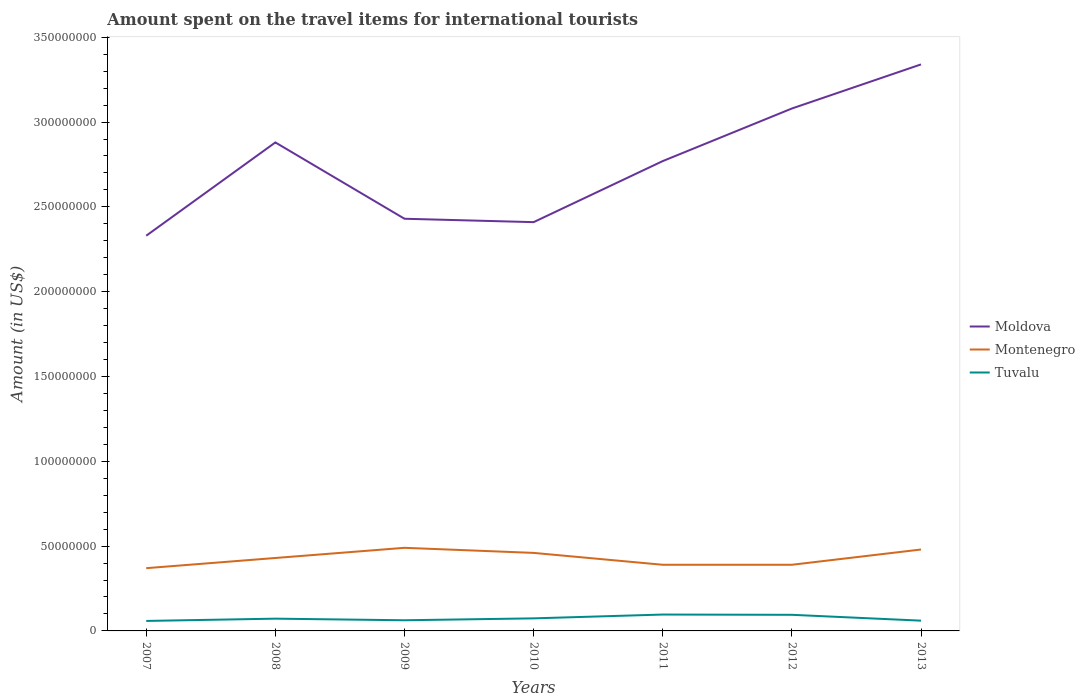How many different coloured lines are there?
Give a very brief answer. 3. Is the number of lines equal to the number of legend labels?
Your answer should be compact. Yes. Across all years, what is the maximum amount spent on the travel items for international tourists in Moldova?
Your answer should be compact. 2.33e+08. In which year was the amount spent on the travel items for international tourists in Montenegro maximum?
Make the answer very short. 2007. What is the total amount spent on the travel items for international tourists in Tuvalu in the graph?
Keep it short and to the point. -2.27e+06. What is the difference between the highest and the second highest amount spent on the travel items for international tourists in Moldova?
Make the answer very short. 1.01e+08. How many years are there in the graph?
Ensure brevity in your answer.  7. What is the difference between two consecutive major ticks on the Y-axis?
Ensure brevity in your answer.  5.00e+07. Are the values on the major ticks of Y-axis written in scientific E-notation?
Provide a succinct answer. No. Does the graph contain any zero values?
Ensure brevity in your answer.  No. How many legend labels are there?
Provide a succinct answer. 3. How are the legend labels stacked?
Your response must be concise. Vertical. What is the title of the graph?
Ensure brevity in your answer.  Amount spent on the travel items for international tourists. Does "Liberia" appear as one of the legend labels in the graph?
Keep it short and to the point. No. What is the label or title of the Y-axis?
Offer a very short reply. Amount (in US$). What is the Amount (in US$) in Moldova in 2007?
Your answer should be compact. 2.33e+08. What is the Amount (in US$) in Montenegro in 2007?
Keep it short and to the point. 3.70e+07. What is the Amount (in US$) of Tuvalu in 2007?
Your answer should be very brief. 5.89e+06. What is the Amount (in US$) of Moldova in 2008?
Ensure brevity in your answer.  2.88e+08. What is the Amount (in US$) of Montenegro in 2008?
Make the answer very short. 4.30e+07. What is the Amount (in US$) in Tuvalu in 2008?
Your answer should be very brief. 7.23e+06. What is the Amount (in US$) of Moldova in 2009?
Make the answer very short. 2.43e+08. What is the Amount (in US$) of Montenegro in 2009?
Your response must be concise. 4.90e+07. What is the Amount (in US$) of Tuvalu in 2009?
Provide a short and direct response. 6.28e+06. What is the Amount (in US$) in Moldova in 2010?
Offer a very short reply. 2.41e+08. What is the Amount (in US$) in Montenegro in 2010?
Give a very brief answer. 4.60e+07. What is the Amount (in US$) in Tuvalu in 2010?
Your answer should be very brief. 7.41e+06. What is the Amount (in US$) of Moldova in 2011?
Offer a terse response. 2.77e+08. What is the Amount (in US$) in Montenegro in 2011?
Keep it short and to the point. 3.90e+07. What is the Amount (in US$) in Tuvalu in 2011?
Give a very brief answer. 9.65e+06. What is the Amount (in US$) in Moldova in 2012?
Your answer should be compact. 3.08e+08. What is the Amount (in US$) in Montenegro in 2012?
Provide a succinct answer. 3.90e+07. What is the Amount (in US$) of Tuvalu in 2012?
Ensure brevity in your answer.  9.50e+06. What is the Amount (in US$) in Moldova in 2013?
Make the answer very short. 3.34e+08. What is the Amount (in US$) in Montenegro in 2013?
Your response must be concise. 4.80e+07. What is the Amount (in US$) in Tuvalu in 2013?
Provide a short and direct response. 6.05e+06. Across all years, what is the maximum Amount (in US$) of Moldova?
Make the answer very short. 3.34e+08. Across all years, what is the maximum Amount (in US$) of Montenegro?
Ensure brevity in your answer.  4.90e+07. Across all years, what is the maximum Amount (in US$) in Tuvalu?
Offer a very short reply. 9.65e+06. Across all years, what is the minimum Amount (in US$) in Moldova?
Keep it short and to the point. 2.33e+08. Across all years, what is the minimum Amount (in US$) of Montenegro?
Offer a terse response. 3.70e+07. Across all years, what is the minimum Amount (in US$) of Tuvalu?
Give a very brief answer. 5.89e+06. What is the total Amount (in US$) in Moldova in the graph?
Make the answer very short. 1.92e+09. What is the total Amount (in US$) of Montenegro in the graph?
Offer a very short reply. 3.01e+08. What is the total Amount (in US$) of Tuvalu in the graph?
Provide a short and direct response. 5.20e+07. What is the difference between the Amount (in US$) of Moldova in 2007 and that in 2008?
Provide a short and direct response. -5.50e+07. What is the difference between the Amount (in US$) of Montenegro in 2007 and that in 2008?
Offer a terse response. -6.00e+06. What is the difference between the Amount (in US$) of Tuvalu in 2007 and that in 2008?
Offer a very short reply. -1.34e+06. What is the difference between the Amount (in US$) of Moldova in 2007 and that in 2009?
Ensure brevity in your answer.  -1.00e+07. What is the difference between the Amount (in US$) of Montenegro in 2007 and that in 2009?
Provide a succinct answer. -1.20e+07. What is the difference between the Amount (in US$) of Tuvalu in 2007 and that in 2009?
Your response must be concise. -3.90e+05. What is the difference between the Amount (in US$) of Moldova in 2007 and that in 2010?
Your answer should be very brief. -8.00e+06. What is the difference between the Amount (in US$) of Montenegro in 2007 and that in 2010?
Your response must be concise. -9.00e+06. What is the difference between the Amount (in US$) in Tuvalu in 2007 and that in 2010?
Make the answer very short. -1.52e+06. What is the difference between the Amount (in US$) in Moldova in 2007 and that in 2011?
Provide a short and direct response. -4.40e+07. What is the difference between the Amount (in US$) in Tuvalu in 2007 and that in 2011?
Keep it short and to the point. -3.76e+06. What is the difference between the Amount (in US$) of Moldova in 2007 and that in 2012?
Provide a succinct answer. -7.50e+07. What is the difference between the Amount (in US$) in Tuvalu in 2007 and that in 2012?
Your response must be concise. -3.61e+06. What is the difference between the Amount (in US$) of Moldova in 2007 and that in 2013?
Your response must be concise. -1.01e+08. What is the difference between the Amount (in US$) of Montenegro in 2007 and that in 2013?
Your response must be concise. -1.10e+07. What is the difference between the Amount (in US$) of Moldova in 2008 and that in 2009?
Keep it short and to the point. 4.50e+07. What is the difference between the Amount (in US$) of Montenegro in 2008 and that in 2009?
Offer a terse response. -6.00e+06. What is the difference between the Amount (in US$) of Tuvalu in 2008 and that in 2009?
Provide a succinct answer. 9.50e+05. What is the difference between the Amount (in US$) of Moldova in 2008 and that in 2010?
Offer a terse response. 4.70e+07. What is the difference between the Amount (in US$) of Montenegro in 2008 and that in 2010?
Give a very brief answer. -3.00e+06. What is the difference between the Amount (in US$) of Moldova in 2008 and that in 2011?
Your answer should be very brief. 1.10e+07. What is the difference between the Amount (in US$) in Tuvalu in 2008 and that in 2011?
Your answer should be very brief. -2.42e+06. What is the difference between the Amount (in US$) in Moldova in 2008 and that in 2012?
Give a very brief answer. -2.00e+07. What is the difference between the Amount (in US$) in Tuvalu in 2008 and that in 2012?
Provide a succinct answer. -2.27e+06. What is the difference between the Amount (in US$) of Moldova in 2008 and that in 2013?
Provide a short and direct response. -4.60e+07. What is the difference between the Amount (in US$) of Montenegro in 2008 and that in 2013?
Make the answer very short. -5.00e+06. What is the difference between the Amount (in US$) in Tuvalu in 2008 and that in 2013?
Provide a short and direct response. 1.18e+06. What is the difference between the Amount (in US$) of Montenegro in 2009 and that in 2010?
Offer a very short reply. 3.00e+06. What is the difference between the Amount (in US$) of Tuvalu in 2009 and that in 2010?
Ensure brevity in your answer.  -1.13e+06. What is the difference between the Amount (in US$) in Moldova in 2009 and that in 2011?
Provide a short and direct response. -3.40e+07. What is the difference between the Amount (in US$) of Montenegro in 2009 and that in 2011?
Your response must be concise. 1.00e+07. What is the difference between the Amount (in US$) of Tuvalu in 2009 and that in 2011?
Provide a succinct answer. -3.37e+06. What is the difference between the Amount (in US$) in Moldova in 2009 and that in 2012?
Your answer should be very brief. -6.50e+07. What is the difference between the Amount (in US$) of Montenegro in 2009 and that in 2012?
Offer a terse response. 1.00e+07. What is the difference between the Amount (in US$) of Tuvalu in 2009 and that in 2012?
Your response must be concise. -3.22e+06. What is the difference between the Amount (in US$) in Moldova in 2009 and that in 2013?
Make the answer very short. -9.10e+07. What is the difference between the Amount (in US$) of Montenegro in 2009 and that in 2013?
Provide a succinct answer. 1.00e+06. What is the difference between the Amount (in US$) in Tuvalu in 2009 and that in 2013?
Offer a very short reply. 2.30e+05. What is the difference between the Amount (in US$) of Moldova in 2010 and that in 2011?
Provide a short and direct response. -3.60e+07. What is the difference between the Amount (in US$) in Montenegro in 2010 and that in 2011?
Offer a very short reply. 7.00e+06. What is the difference between the Amount (in US$) of Tuvalu in 2010 and that in 2011?
Keep it short and to the point. -2.24e+06. What is the difference between the Amount (in US$) in Moldova in 2010 and that in 2012?
Your answer should be compact. -6.70e+07. What is the difference between the Amount (in US$) of Tuvalu in 2010 and that in 2012?
Your response must be concise. -2.09e+06. What is the difference between the Amount (in US$) in Moldova in 2010 and that in 2013?
Give a very brief answer. -9.30e+07. What is the difference between the Amount (in US$) in Tuvalu in 2010 and that in 2013?
Offer a terse response. 1.36e+06. What is the difference between the Amount (in US$) in Moldova in 2011 and that in 2012?
Your response must be concise. -3.10e+07. What is the difference between the Amount (in US$) in Montenegro in 2011 and that in 2012?
Your answer should be compact. 0. What is the difference between the Amount (in US$) in Moldova in 2011 and that in 2013?
Your response must be concise. -5.70e+07. What is the difference between the Amount (in US$) in Montenegro in 2011 and that in 2013?
Offer a terse response. -9.00e+06. What is the difference between the Amount (in US$) in Tuvalu in 2011 and that in 2013?
Give a very brief answer. 3.60e+06. What is the difference between the Amount (in US$) of Moldova in 2012 and that in 2013?
Provide a succinct answer. -2.60e+07. What is the difference between the Amount (in US$) of Montenegro in 2012 and that in 2013?
Ensure brevity in your answer.  -9.00e+06. What is the difference between the Amount (in US$) in Tuvalu in 2012 and that in 2013?
Provide a short and direct response. 3.45e+06. What is the difference between the Amount (in US$) of Moldova in 2007 and the Amount (in US$) of Montenegro in 2008?
Provide a succinct answer. 1.90e+08. What is the difference between the Amount (in US$) of Moldova in 2007 and the Amount (in US$) of Tuvalu in 2008?
Make the answer very short. 2.26e+08. What is the difference between the Amount (in US$) of Montenegro in 2007 and the Amount (in US$) of Tuvalu in 2008?
Offer a very short reply. 2.98e+07. What is the difference between the Amount (in US$) in Moldova in 2007 and the Amount (in US$) in Montenegro in 2009?
Your response must be concise. 1.84e+08. What is the difference between the Amount (in US$) in Moldova in 2007 and the Amount (in US$) in Tuvalu in 2009?
Provide a succinct answer. 2.27e+08. What is the difference between the Amount (in US$) in Montenegro in 2007 and the Amount (in US$) in Tuvalu in 2009?
Your answer should be very brief. 3.07e+07. What is the difference between the Amount (in US$) in Moldova in 2007 and the Amount (in US$) in Montenegro in 2010?
Your answer should be compact. 1.87e+08. What is the difference between the Amount (in US$) in Moldova in 2007 and the Amount (in US$) in Tuvalu in 2010?
Provide a short and direct response. 2.26e+08. What is the difference between the Amount (in US$) in Montenegro in 2007 and the Amount (in US$) in Tuvalu in 2010?
Your answer should be compact. 2.96e+07. What is the difference between the Amount (in US$) of Moldova in 2007 and the Amount (in US$) of Montenegro in 2011?
Give a very brief answer. 1.94e+08. What is the difference between the Amount (in US$) of Moldova in 2007 and the Amount (in US$) of Tuvalu in 2011?
Make the answer very short. 2.23e+08. What is the difference between the Amount (in US$) in Montenegro in 2007 and the Amount (in US$) in Tuvalu in 2011?
Provide a succinct answer. 2.74e+07. What is the difference between the Amount (in US$) in Moldova in 2007 and the Amount (in US$) in Montenegro in 2012?
Provide a short and direct response. 1.94e+08. What is the difference between the Amount (in US$) of Moldova in 2007 and the Amount (in US$) of Tuvalu in 2012?
Give a very brief answer. 2.24e+08. What is the difference between the Amount (in US$) in Montenegro in 2007 and the Amount (in US$) in Tuvalu in 2012?
Ensure brevity in your answer.  2.75e+07. What is the difference between the Amount (in US$) in Moldova in 2007 and the Amount (in US$) in Montenegro in 2013?
Give a very brief answer. 1.85e+08. What is the difference between the Amount (in US$) in Moldova in 2007 and the Amount (in US$) in Tuvalu in 2013?
Make the answer very short. 2.27e+08. What is the difference between the Amount (in US$) in Montenegro in 2007 and the Amount (in US$) in Tuvalu in 2013?
Give a very brief answer. 3.10e+07. What is the difference between the Amount (in US$) of Moldova in 2008 and the Amount (in US$) of Montenegro in 2009?
Your response must be concise. 2.39e+08. What is the difference between the Amount (in US$) in Moldova in 2008 and the Amount (in US$) in Tuvalu in 2009?
Provide a short and direct response. 2.82e+08. What is the difference between the Amount (in US$) of Montenegro in 2008 and the Amount (in US$) of Tuvalu in 2009?
Your response must be concise. 3.67e+07. What is the difference between the Amount (in US$) of Moldova in 2008 and the Amount (in US$) of Montenegro in 2010?
Make the answer very short. 2.42e+08. What is the difference between the Amount (in US$) in Moldova in 2008 and the Amount (in US$) in Tuvalu in 2010?
Make the answer very short. 2.81e+08. What is the difference between the Amount (in US$) of Montenegro in 2008 and the Amount (in US$) of Tuvalu in 2010?
Make the answer very short. 3.56e+07. What is the difference between the Amount (in US$) in Moldova in 2008 and the Amount (in US$) in Montenegro in 2011?
Your answer should be compact. 2.49e+08. What is the difference between the Amount (in US$) in Moldova in 2008 and the Amount (in US$) in Tuvalu in 2011?
Your response must be concise. 2.78e+08. What is the difference between the Amount (in US$) in Montenegro in 2008 and the Amount (in US$) in Tuvalu in 2011?
Provide a succinct answer. 3.34e+07. What is the difference between the Amount (in US$) of Moldova in 2008 and the Amount (in US$) of Montenegro in 2012?
Offer a terse response. 2.49e+08. What is the difference between the Amount (in US$) in Moldova in 2008 and the Amount (in US$) in Tuvalu in 2012?
Provide a short and direct response. 2.78e+08. What is the difference between the Amount (in US$) in Montenegro in 2008 and the Amount (in US$) in Tuvalu in 2012?
Offer a very short reply. 3.35e+07. What is the difference between the Amount (in US$) of Moldova in 2008 and the Amount (in US$) of Montenegro in 2013?
Give a very brief answer. 2.40e+08. What is the difference between the Amount (in US$) of Moldova in 2008 and the Amount (in US$) of Tuvalu in 2013?
Provide a succinct answer. 2.82e+08. What is the difference between the Amount (in US$) of Montenegro in 2008 and the Amount (in US$) of Tuvalu in 2013?
Provide a succinct answer. 3.70e+07. What is the difference between the Amount (in US$) in Moldova in 2009 and the Amount (in US$) in Montenegro in 2010?
Make the answer very short. 1.97e+08. What is the difference between the Amount (in US$) of Moldova in 2009 and the Amount (in US$) of Tuvalu in 2010?
Make the answer very short. 2.36e+08. What is the difference between the Amount (in US$) in Montenegro in 2009 and the Amount (in US$) in Tuvalu in 2010?
Your response must be concise. 4.16e+07. What is the difference between the Amount (in US$) of Moldova in 2009 and the Amount (in US$) of Montenegro in 2011?
Your answer should be very brief. 2.04e+08. What is the difference between the Amount (in US$) in Moldova in 2009 and the Amount (in US$) in Tuvalu in 2011?
Provide a succinct answer. 2.33e+08. What is the difference between the Amount (in US$) in Montenegro in 2009 and the Amount (in US$) in Tuvalu in 2011?
Ensure brevity in your answer.  3.94e+07. What is the difference between the Amount (in US$) in Moldova in 2009 and the Amount (in US$) in Montenegro in 2012?
Offer a very short reply. 2.04e+08. What is the difference between the Amount (in US$) of Moldova in 2009 and the Amount (in US$) of Tuvalu in 2012?
Offer a terse response. 2.34e+08. What is the difference between the Amount (in US$) in Montenegro in 2009 and the Amount (in US$) in Tuvalu in 2012?
Provide a succinct answer. 3.95e+07. What is the difference between the Amount (in US$) in Moldova in 2009 and the Amount (in US$) in Montenegro in 2013?
Keep it short and to the point. 1.95e+08. What is the difference between the Amount (in US$) in Moldova in 2009 and the Amount (in US$) in Tuvalu in 2013?
Ensure brevity in your answer.  2.37e+08. What is the difference between the Amount (in US$) of Montenegro in 2009 and the Amount (in US$) of Tuvalu in 2013?
Provide a succinct answer. 4.30e+07. What is the difference between the Amount (in US$) in Moldova in 2010 and the Amount (in US$) in Montenegro in 2011?
Offer a very short reply. 2.02e+08. What is the difference between the Amount (in US$) in Moldova in 2010 and the Amount (in US$) in Tuvalu in 2011?
Make the answer very short. 2.31e+08. What is the difference between the Amount (in US$) in Montenegro in 2010 and the Amount (in US$) in Tuvalu in 2011?
Provide a short and direct response. 3.64e+07. What is the difference between the Amount (in US$) in Moldova in 2010 and the Amount (in US$) in Montenegro in 2012?
Offer a very short reply. 2.02e+08. What is the difference between the Amount (in US$) of Moldova in 2010 and the Amount (in US$) of Tuvalu in 2012?
Offer a terse response. 2.32e+08. What is the difference between the Amount (in US$) of Montenegro in 2010 and the Amount (in US$) of Tuvalu in 2012?
Keep it short and to the point. 3.65e+07. What is the difference between the Amount (in US$) in Moldova in 2010 and the Amount (in US$) in Montenegro in 2013?
Ensure brevity in your answer.  1.93e+08. What is the difference between the Amount (in US$) of Moldova in 2010 and the Amount (in US$) of Tuvalu in 2013?
Provide a succinct answer. 2.35e+08. What is the difference between the Amount (in US$) in Montenegro in 2010 and the Amount (in US$) in Tuvalu in 2013?
Make the answer very short. 4.00e+07. What is the difference between the Amount (in US$) in Moldova in 2011 and the Amount (in US$) in Montenegro in 2012?
Make the answer very short. 2.38e+08. What is the difference between the Amount (in US$) of Moldova in 2011 and the Amount (in US$) of Tuvalu in 2012?
Make the answer very short. 2.68e+08. What is the difference between the Amount (in US$) of Montenegro in 2011 and the Amount (in US$) of Tuvalu in 2012?
Provide a succinct answer. 2.95e+07. What is the difference between the Amount (in US$) in Moldova in 2011 and the Amount (in US$) in Montenegro in 2013?
Your answer should be compact. 2.29e+08. What is the difference between the Amount (in US$) of Moldova in 2011 and the Amount (in US$) of Tuvalu in 2013?
Provide a short and direct response. 2.71e+08. What is the difference between the Amount (in US$) in Montenegro in 2011 and the Amount (in US$) in Tuvalu in 2013?
Your answer should be very brief. 3.30e+07. What is the difference between the Amount (in US$) in Moldova in 2012 and the Amount (in US$) in Montenegro in 2013?
Your answer should be compact. 2.60e+08. What is the difference between the Amount (in US$) of Moldova in 2012 and the Amount (in US$) of Tuvalu in 2013?
Make the answer very short. 3.02e+08. What is the difference between the Amount (in US$) in Montenegro in 2012 and the Amount (in US$) in Tuvalu in 2013?
Keep it short and to the point. 3.30e+07. What is the average Amount (in US$) in Moldova per year?
Your answer should be compact. 2.75e+08. What is the average Amount (in US$) of Montenegro per year?
Your response must be concise. 4.30e+07. What is the average Amount (in US$) in Tuvalu per year?
Make the answer very short. 7.43e+06. In the year 2007, what is the difference between the Amount (in US$) in Moldova and Amount (in US$) in Montenegro?
Keep it short and to the point. 1.96e+08. In the year 2007, what is the difference between the Amount (in US$) of Moldova and Amount (in US$) of Tuvalu?
Your answer should be very brief. 2.27e+08. In the year 2007, what is the difference between the Amount (in US$) of Montenegro and Amount (in US$) of Tuvalu?
Provide a short and direct response. 3.11e+07. In the year 2008, what is the difference between the Amount (in US$) in Moldova and Amount (in US$) in Montenegro?
Make the answer very short. 2.45e+08. In the year 2008, what is the difference between the Amount (in US$) of Moldova and Amount (in US$) of Tuvalu?
Keep it short and to the point. 2.81e+08. In the year 2008, what is the difference between the Amount (in US$) in Montenegro and Amount (in US$) in Tuvalu?
Your answer should be compact. 3.58e+07. In the year 2009, what is the difference between the Amount (in US$) in Moldova and Amount (in US$) in Montenegro?
Your answer should be very brief. 1.94e+08. In the year 2009, what is the difference between the Amount (in US$) of Moldova and Amount (in US$) of Tuvalu?
Provide a short and direct response. 2.37e+08. In the year 2009, what is the difference between the Amount (in US$) in Montenegro and Amount (in US$) in Tuvalu?
Offer a very short reply. 4.27e+07. In the year 2010, what is the difference between the Amount (in US$) of Moldova and Amount (in US$) of Montenegro?
Ensure brevity in your answer.  1.95e+08. In the year 2010, what is the difference between the Amount (in US$) of Moldova and Amount (in US$) of Tuvalu?
Your answer should be compact. 2.34e+08. In the year 2010, what is the difference between the Amount (in US$) in Montenegro and Amount (in US$) in Tuvalu?
Your response must be concise. 3.86e+07. In the year 2011, what is the difference between the Amount (in US$) in Moldova and Amount (in US$) in Montenegro?
Provide a short and direct response. 2.38e+08. In the year 2011, what is the difference between the Amount (in US$) of Moldova and Amount (in US$) of Tuvalu?
Keep it short and to the point. 2.67e+08. In the year 2011, what is the difference between the Amount (in US$) of Montenegro and Amount (in US$) of Tuvalu?
Ensure brevity in your answer.  2.94e+07. In the year 2012, what is the difference between the Amount (in US$) of Moldova and Amount (in US$) of Montenegro?
Provide a succinct answer. 2.69e+08. In the year 2012, what is the difference between the Amount (in US$) of Moldova and Amount (in US$) of Tuvalu?
Make the answer very short. 2.98e+08. In the year 2012, what is the difference between the Amount (in US$) of Montenegro and Amount (in US$) of Tuvalu?
Give a very brief answer. 2.95e+07. In the year 2013, what is the difference between the Amount (in US$) in Moldova and Amount (in US$) in Montenegro?
Keep it short and to the point. 2.86e+08. In the year 2013, what is the difference between the Amount (in US$) of Moldova and Amount (in US$) of Tuvalu?
Your response must be concise. 3.28e+08. In the year 2013, what is the difference between the Amount (in US$) in Montenegro and Amount (in US$) in Tuvalu?
Make the answer very short. 4.20e+07. What is the ratio of the Amount (in US$) of Moldova in 2007 to that in 2008?
Your answer should be very brief. 0.81. What is the ratio of the Amount (in US$) in Montenegro in 2007 to that in 2008?
Provide a succinct answer. 0.86. What is the ratio of the Amount (in US$) of Tuvalu in 2007 to that in 2008?
Keep it short and to the point. 0.81. What is the ratio of the Amount (in US$) in Moldova in 2007 to that in 2009?
Ensure brevity in your answer.  0.96. What is the ratio of the Amount (in US$) in Montenegro in 2007 to that in 2009?
Your response must be concise. 0.76. What is the ratio of the Amount (in US$) of Tuvalu in 2007 to that in 2009?
Give a very brief answer. 0.94. What is the ratio of the Amount (in US$) of Moldova in 2007 to that in 2010?
Offer a very short reply. 0.97. What is the ratio of the Amount (in US$) of Montenegro in 2007 to that in 2010?
Ensure brevity in your answer.  0.8. What is the ratio of the Amount (in US$) in Tuvalu in 2007 to that in 2010?
Ensure brevity in your answer.  0.79. What is the ratio of the Amount (in US$) in Moldova in 2007 to that in 2011?
Your answer should be very brief. 0.84. What is the ratio of the Amount (in US$) of Montenegro in 2007 to that in 2011?
Your answer should be very brief. 0.95. What is the ratio of the Amount (in US$) in Tuvalu in 2007 to that in 2011?
Keep it short and to the point. 0.61. What is the ratio of the Amount (in US$) in Moldova in 2007 to that in 2012?
Your response must be concise. 0.76. What is the ratio of the Amount (in US$) of Montenegro in 2007 to that in 2012?
Your answer should be compact. 0.95. What is the ratio of the Amount (in US$) in Tuvalu in 2007 to that in 2012?
Your answer should be compact. 0.62. What is the ratio of the Amount (in US$) of Moldova in 2007 to that in 2013?
Ensure brevity in your answer.  0.7. What is the ratio of the Amount (in US$) of Montenegro in 2007 to that in 2013?
Make the answer very short. 0.77. What is the ratio of the Amount (in US$) of Tuvalu in 2007 to that in 2013?
Provide a short and direct response. 0.97. What is the ratio of the Amount (in US$) of Moldova in 2008 to that in 2009?
Offer a very short reply. 1.19. What is the ratio of the Amount (in US$) in Montenegro in 2008 to that in 2009?
Your answer should be compact. 0.88. What is the ratio of the Amount (in US$) of Tuvalu in 2008 to that in 2009?
Keep it short and to the point. 1.15. What is the ratio of the Amount (in US$) of Moldova in 2008 to that in 2010?
Ensure brevity in your answer.  1.2. What is the ratio of the Amount (in US$) in Montenegro in 2008 to that in 2010?
Offer a very short reply. 0.93. What is the ratio of the Amount (in US$) in Tuvalu in 2008 to that in 2010?
Your response must be concise. 0.98. What is the ratio of the Amount (in US$) in Moldova in 2008 to that in 2011?
Offer a terse response. 1.04. What is the ratio of the Amount (in US$) in Montenegro in 2008 to that in 2011?
Ensure brevity in your answer.  1.1. What is the ratio of the Amount (in US$) in Tuvalu in 2008 to that in 2011?
Make the answer very short. 0.75. What is the ratio of the Amount (in US$) of Moldova in 2008 to that in 2012?
Offer a terse response. 0.94. What is the ratio of the Amount (in US$) of Montenegro in 2008 to that in 2012?
Provide a succinct answer. 1.1. What is the ratio of the Amount (in US$) of Tuvalu in 2008 to that in 2012?
Ensure brevity in your answer.  0.76. What is the ratio of the Amount (in US$) of Moldova in 2008 to that in 2013?
Your response must be concise. 0.86. What is the ratio of the Amount (in US$) of Montenegro in 2008 to that in 2013?
Offer a terse response. 0.9. What is the ratio of the Amount (in US$) in Tuvalu in 2008 to that in 2013?
Give a very brief answer. 1.2. What is the ratio of the Amount (in US$) in Moldova in 2009 to that in 2010?
Provide a succinct answer. 1.01. What is the ratio of the Amount (in US$) of Montenegro in 2009 to that in 2010?
Ensure brevity in your answer.  1.07. What is the ratio of the Amount (in US$) of Tuvalu in 2009 to that in 2010?
Provide a succinct answer. 0.85. What is the ratio of the Amount (in US$) of Moldova in 2009 to that in 2011?
Provide a succinct answer. 0.88. What is the ratio of the Amount (in US$) in Montenegro in 2009 to that in 2011?
Your answer should be very brief. 1.26. What is the ratio of the Amount (in US$) in Tuvalu in 2009 to that in 2011?
Keep it short and to the point. 0.65. What is the ratio of the Amount (in US$) of Moldova in 2009 to that in 2012?
Your answer should be compact. 0.79. What is the ratio of the Amount (in US$) in Montenegro in 2009 to that in 2012?
Your answer should be very brief. 1.26. What is the ratio of the Amount (in US$) of Tuvalu in 2009 to that in 2012?
Ensure brevity in your answer.  0.66. What is the ratio of the Amount (in US$) in Moldova in 2009 to that in 2013?
Your answer should be compact. 0.73. What is the ratio of the Amount (in US$) of Montenegro in 2009 to that in 2013?
Your answer should be very brief. 1.02. What is the ratio of the Amount (in US$) of Tuvalu in 2009 to that in 2013?
Provide a succinct answer. 1.04. What is the ratio of the Amount (in US$) in Moldova in 2010 to that in 2011?
Ensure brevity in your answer.  0.87. What is the ratio of the Amount (in US$) of Montenegro in 2010 to that in 2011?
Offer a terse response. 1.18. What is the ratio of the Amount (in US$) of Tuvalu in 2010 to that in 2011?
Keep it short and to the point. 0.77. What is the ratio of the Amount (in US$) in Moldova in 2010 to that in 2012?
Your answer should be very brief. 0.78. What is the ratio of the Amount (in US$) in Montenegro in 2010 to that in 2012?
Make the answer very short. 1.18. What is the ratio of the Amount (in US$) in Tuvalu in 2010 to that in 2012?
Keep it short and to the point. 0.78. What is the ratio of the Amount (in US$) in Moldova in 2010 to that in 2013?
Provide a succinct answer. 0.72. What is the ratio of the Amount (in US$) of Tuvalu in 2010 to that in 2013?
Provide a short and direct response. 1.22. What is the ratio of the Amount (in US$) of Moldova in 2011 to that in 2012?
Offer a terse response. 0.9. What is the ratio of the Amount (in US$) of Montenegro in 2011 to that in 2012?
Your answer should be very brief. 1. What is the ratio of the Amount (in US$) of Tuvalu in 2011 to that in 2012?
Offer a very short reply. 1.02. What is the ratio of the Amount (in US$) in Moldova in 2011 to that in 2013?
Provide a succinct answer. 0.83. What is the ratio of the Amount (in US$) of Montenegro in 2011 to that in 2013?
Your response must be concise. 0.81. What is the ratio of the Amount (in US$) in Tuvalu in 2011 to that in 2013?
Give a very brief answer. 1.59. What is the ratio of the Amount (in US$) in Moldova in 2012 to that in 2013?
Keep it short and to the point. 0.92. What is the ratio of the Amount (in US$) in Montenegro in 2012 to that in 2013?
Your response must be concise. 0.81. What is the ratio of the Amount (in US$) in Tuvalu in 2012 to that in 2013?
Ensure brevity in your answer.  1.57. What is the difference between the highest and the second highest Amount (in US$) in Moldova?
Your answer should be compact. 2.60e+07. What is the difference between the highest and the second highest Amount (in US$) of Tuvalu?
Give a very brief answer. 1.50e+05. What is the difference between the highest and the lowest Amount (in US$) in Moldova?
Provide a succinct answer. 1.01e+08. What is the difference between the highest and the lowest Amount (in US$) of Tuvalu?
Make the answer very short. 3.76e+06. 